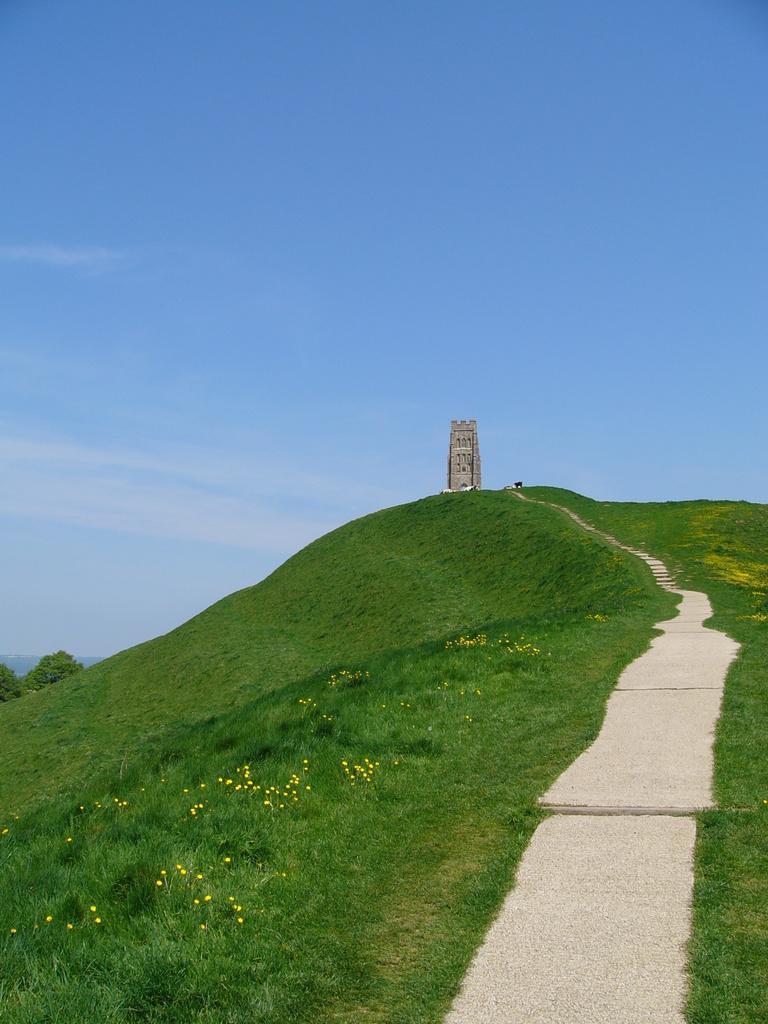Please provide a concise description of this image. In this picture I can see grass and couple of trees and looks like a monument and a blue cloudy sky. 